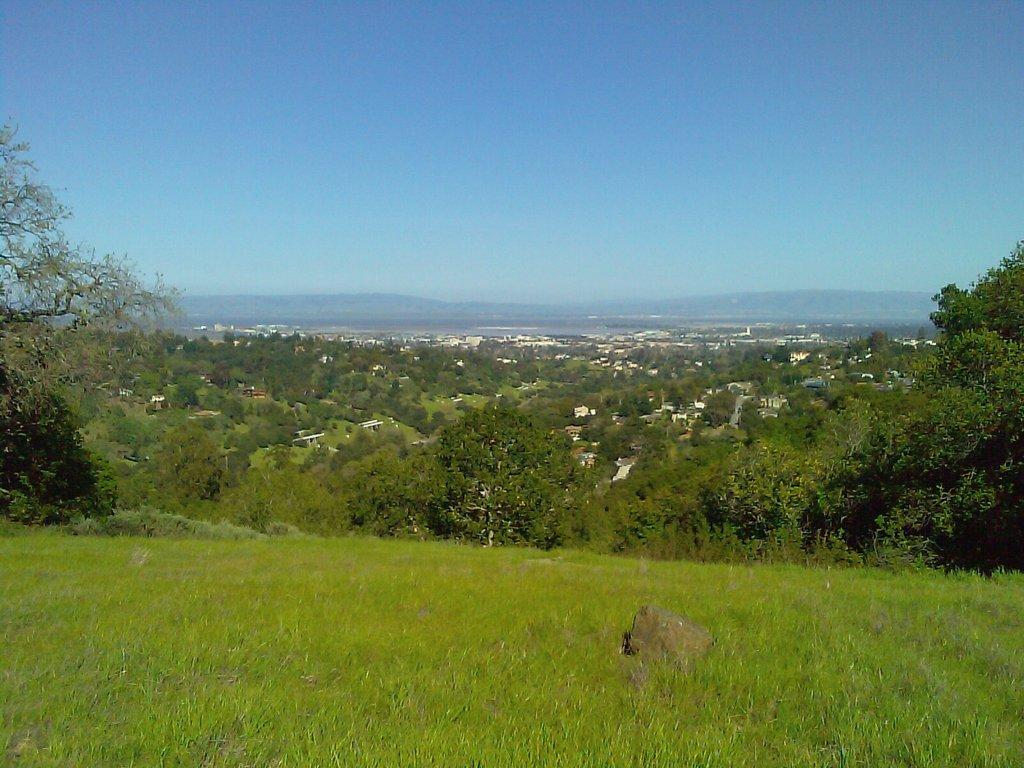What type of vegetation is at the bottom of the image? There is grass at the bottom of the image. What can be seen in the background of the image? There are trees and buildings in the background of the image. What is visible at the top of the image? The sky is visible at the top of the image. How many jars of salt are present in the image? There are no jars of salt present in the image. Is there a visitor interacting with the trees in the background? There is no visitor present in the image. 